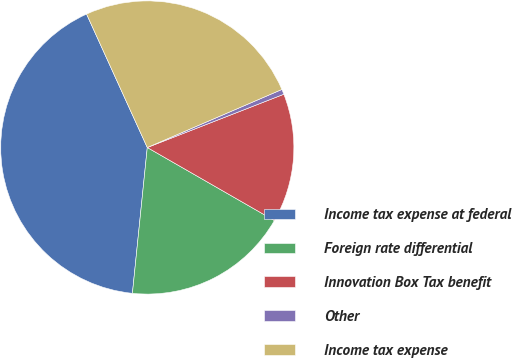Convert chart to OTSL. <chart><loc_0><loc_0><loc_500><loc_500><pie_chart><fcel>Income tax expense at federal<fcel>Foreign rate differential<fcel>Innovation Box Tax benefit<fcel>Other<fcel>Income tax expense<nl><fcel>41.59%<fcel>18.32%<fcel>14.22%<fcel>0.56%<fcel>25.32%<nl></chart> 